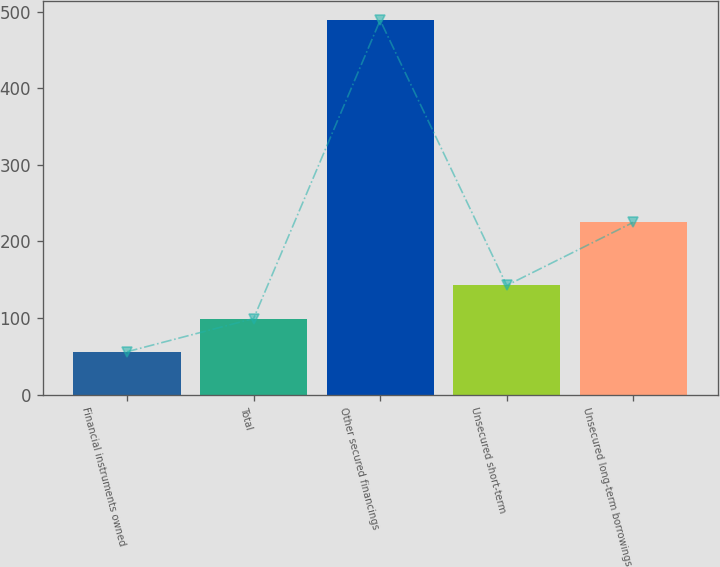Convert chart to OTSL. <chart><loc_0><loc_0><loc_500><loc_500><bar_chart><fcel>Financial instruments owned<fcel>Total<fcel>Other secured financings<fcel>Unsecured short-term<fcel>Unsecured long-term borrowings<nl><fcel>56<fcel>99.3<fcel>489<fcel>142.6<fcel>225<nl></chart> 